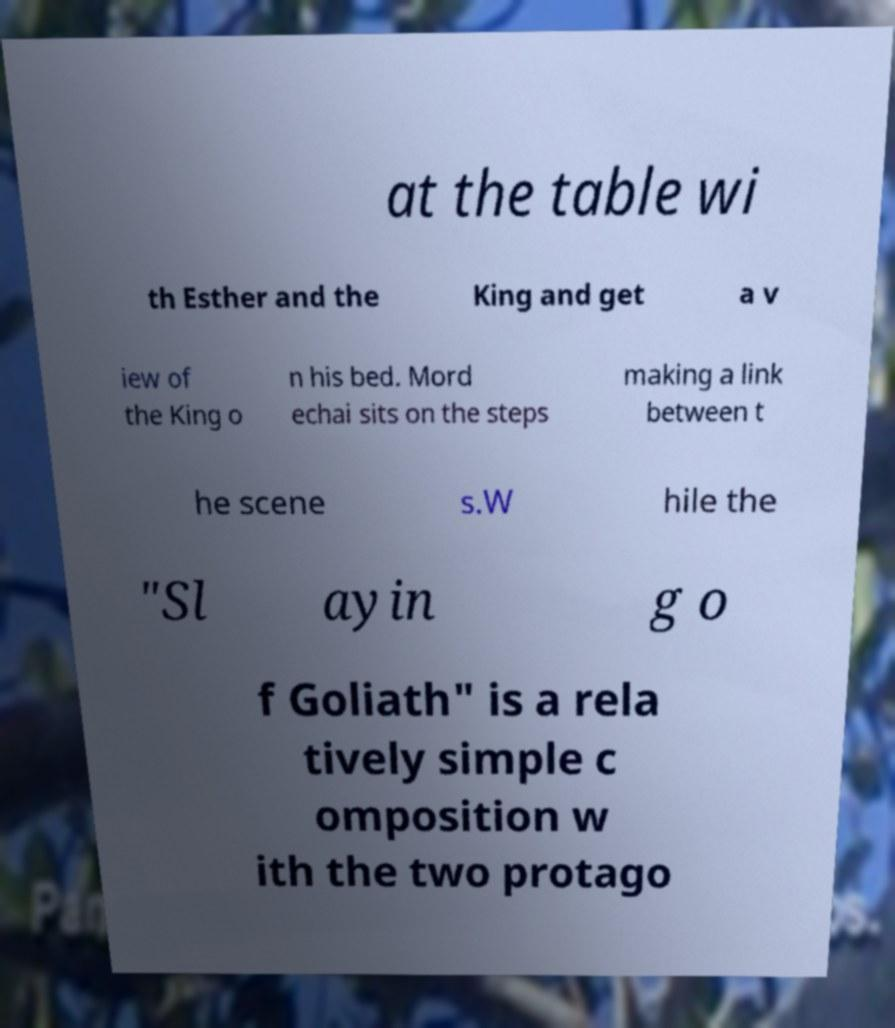There's text embedded in this image that I need extracted. Can you transcribe it verbatim? at the table wi th Esther and the King and get a v iew of the King o n his bed. Mord echai sits on the steps making a link between t he scene s.W hile the "Sl ayin g o f Goliath" is a rela tively simple c omposition w ith the two protago 